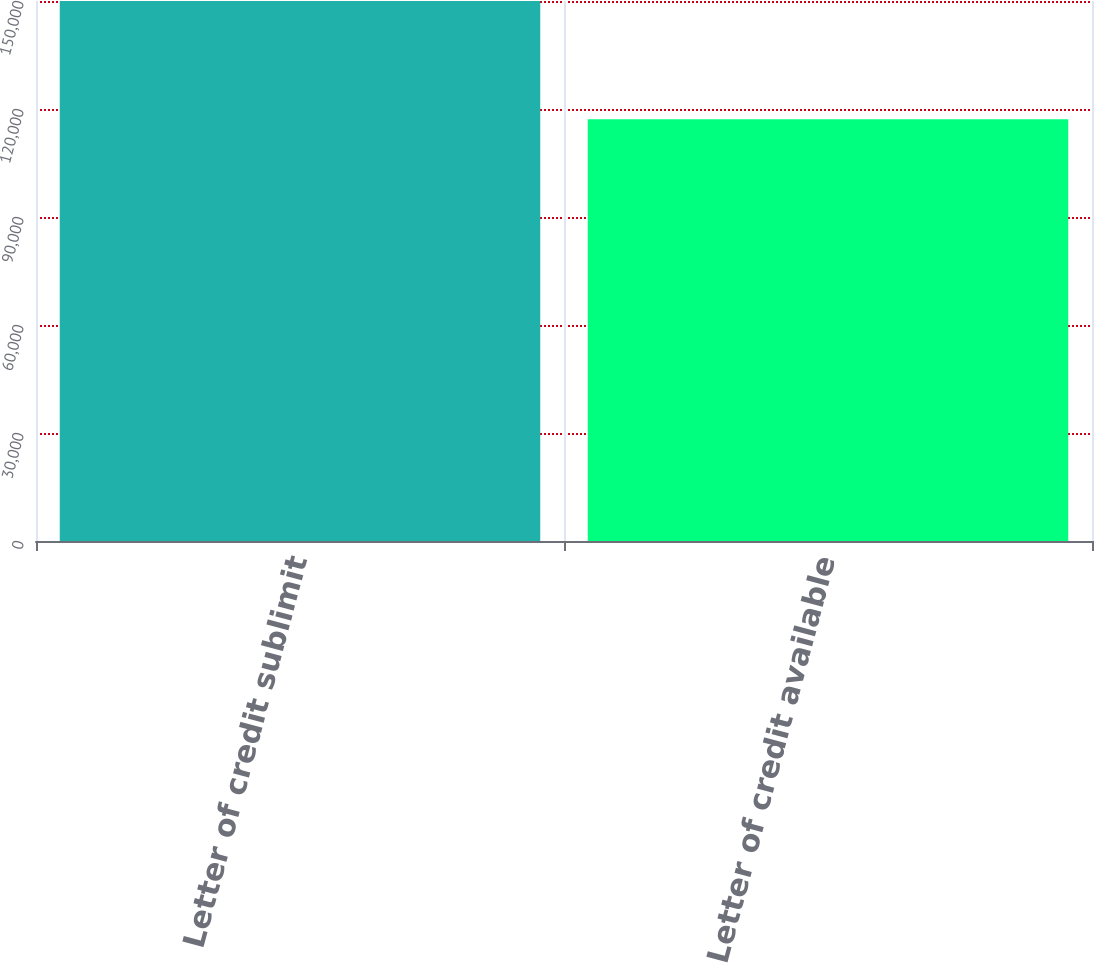<chart> <loc_0><loc_0><loc_500><loc_500><bar_chart><fcel>Letter of credit sublimit<fcel>Letter of credit available<nl><fcel>150000<fcel>117137<nl></chart> 